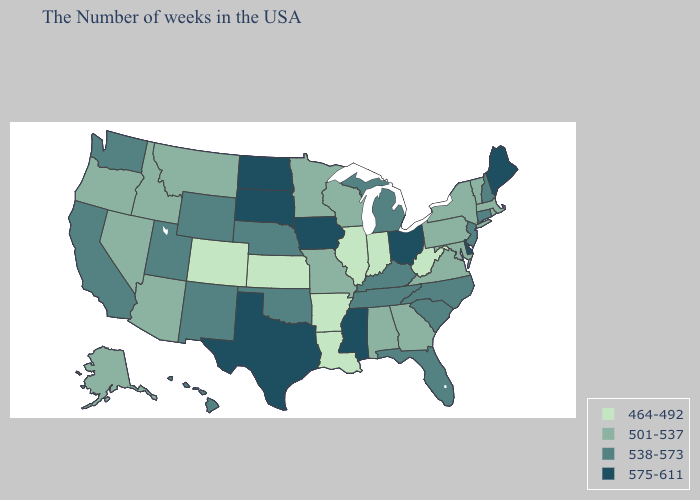Is the legend a continuous bar?
Write a very short answer. No. Does Rhode Island have the highest value in the Northeast?
Be succinct. No. Among the states that border Virginia , does North Carolina have the lowest value?
Concise answer only. No. Does the first symbol in the legend represent the smallest category?
Concise answer only. Yes. Does Mississippi have the highest value in the USA?
Short answer required. Yes. What is the lowest value in the USA?
Concise answer only. 464-492. What is the lowest value in states that border Tennessee?
Quick response, please. 464-492. What is the lowest value in the West?
Be succinct. 464-492. Is the legend a continuous bar?
Keep it brief. No. Is the legend a continuous bar?
Be succinct. No. Does the first symbol in the legend represent the smallest category?
Be succinct. Yes. Among the states that border Delaware , which have the highest value?
Write a very short answer. New Jersey. Does the first symbol in the legend represent the smallest category?
Write a very short answer. Yes. What is the lowest value in states that border New Mexico?
Answer briefly. 464-492. Does North Carolina have a lower value than Iowa?
Keep it brief. Yes. 